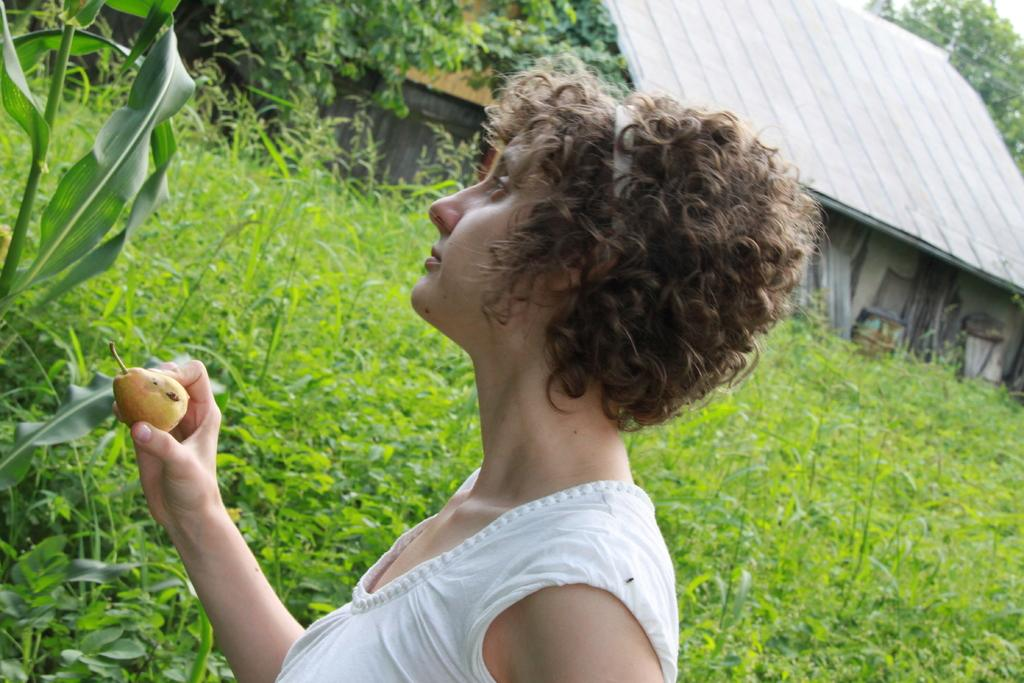What is the main subject of the image? There is a woman standing in the middle of the image. What is the woman holding in the image? The woman is holding a fruit. What type of vegetation can be seen in the image? There are plants and trees in the image. What type of structure is present in the image? There is a shed in the image. Is there any ice visible in the image? There is no ice present in the image. Is there any indication of a party happening in the image? There is no indication of a party in the image. 